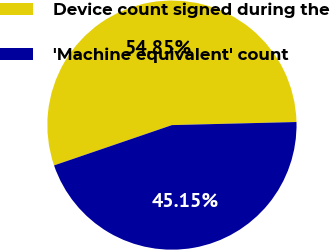<chart> <loc_0><loc_0><loc_500><loc_500><pie_chart><fcel>Device count signed during the<fcel>'Machine equivalent' count<nl><fcel>54.85%<fcel>45.15%<nl></chart> 